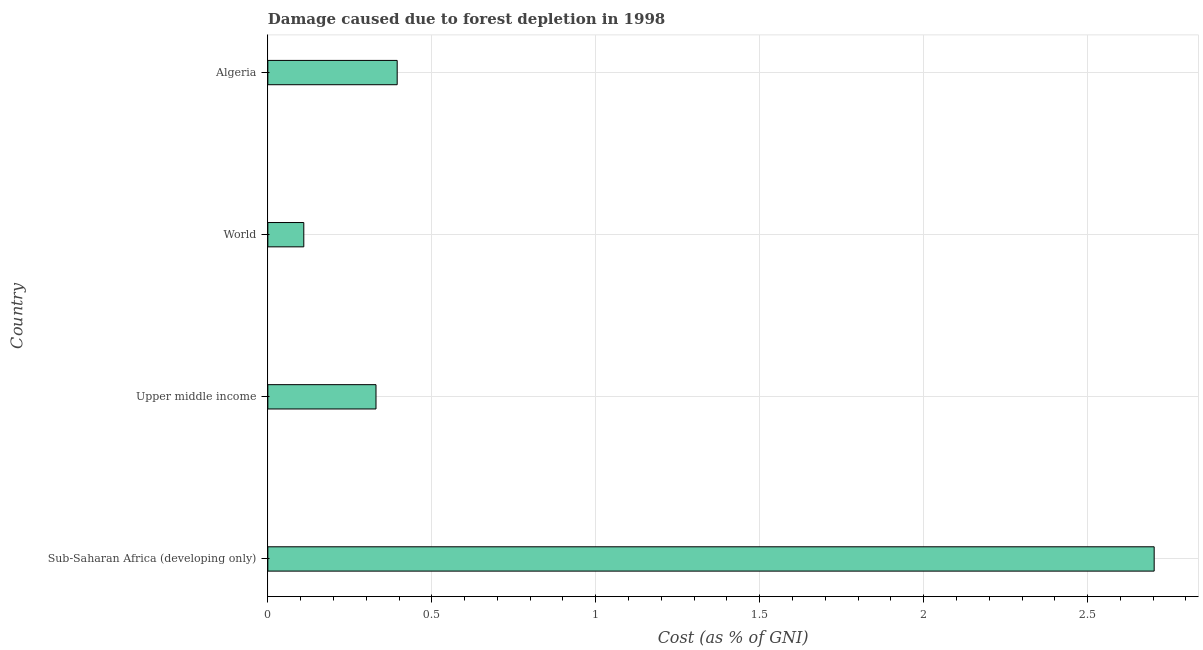Does the graph contain any zero values?
Your response must be concise. No. What is the title of the graph?
Offer a terse response. Damage caused due to forest depletion in 1998. What is the label or title of the X-axis?
Keep it short and to the point. Cost (as % of GNI). What is the label or title of the Y-axis?
Your answer should be compact. Country. What is the damage caused due to forest depletion in Sub-Saharan Africa (developing only)?
Provide a short and direct response. 2.7. Across all countries, what is the maximum damage caused due to forest depletion?
Make the answer very short. 2.7. Across all countries, what is the minimum damage caused due to forest depletion?
Offer a very short reply. 0.11. In which country was the damage caused due to forest depletion maximum?
Give a very brief answer. Sub-Saharan Africa (developing only). What is the sum of the damage caused due to forest depletion?
Provide a short and direct response. 3.54. What is the difference between the damage caused due to forest depletion in Algeria and Sub-Saharan Africa (developing only)?
Give a very brief answer. -2.31. What is the average damage caused due to forest depletion per country?
Your answer should be very brief. 0.88. What is the median damage caused due to forest depletion?
Keep it short and to the point. 0.36. In how many countries, is the damage caused due to forest depletion greater than 2.6 %?
Your answer should be very brief. 1. What is the ratio of the damage caused due to forest depletion in Algeria to that in World?
Provide a short and direct response. 3.6. Is the damage caused due to forest depletion in Algeria less than that in World?
Provide a succinct answer. No. What is the difference between the highest and the second highest damage caused due to forest depletion?
Provide a short and direct response. 2.31. Is the sum of the damage caused due to forest depletion in Algeria and World greater than the maximum damage caused due to forest depletion across all countries?
Your answer should be compact. No. What is the difference between the highest and the lowest damage caused due to forest depletion?
Ensure brevity in your answer.  2.59. In how many countries, is the damage caused due to forest depletion greater than the average damage caused due to forest depletion taken over all countries?
Offer a terse response. 1. How many countries are there in the graph?
Your answer should be very brief. 4. What is the Cost (as % of GNI) in Sub-Saharan Africa (developing only)?
Your answer should be compact. 2.7. What is the Cost (as % of GNI) in Upper middle income?
Make the answer very short. 0.33. What is the Cost (as % of GNI) in World?
Your answer should be compact. 0.11. What is the Cost (as % of GNI) in Algeria?
Your answer should be compact. 0.39. What is the difference between the Cost (as % of GNI) in Sub-Saharan Africa (developing only) and Upper middle income?
Your response must be concise. 2.37. What is the difference between the Cost (as % of GNI) in Sub-Saharan Africa (developing only) and World?
Provide a succinct answer. 2.59. What is the difference between the Cost (as % of GNI) in Sub-Saharan Africa (developing only) and Algeria?
Give a very brief answer. 2.31. What is the difference between the Cost (as % of GNI) in Upper middle income and World?
Offer a very short reply. 0.22. What is the difference between the Cost (as % of GNI) in Upper middle income and Algeria?
Your answer should be very brief. -0.06. What is the difference between the Cost (as % of GNI) in World and Algeria?
Your response must be concise. -0.28. What is the ratio of the Cost (as % of GNI) in Sub-Saharan Africa (developing only) to that in Upper middle income?
Make the answer very short. 8.2. What is the ratio of the Cost (as % of GNI) in Sub-Saharan Africa (developing only) to that in World?
Your response must be concise. 24.66. What is the ratio of the Cost (as % of GNI) in Sub-Saharan Africa (developing only) to that in Algeria?
Give a very brief answer. 6.85. What is the ratio of the Cost (as % of GNI) in Upper middle income to that in World?
Your answer should be very brief. 3.01. What is the ratio of the Cost (as % of GNI) in Upper middle income to that in Algeria?
Give a very brief answer. 0.84. What is the ratio of the Cost (as % of GNI) in World to that in Algeria?
Your answer should be compact. 0.28. 